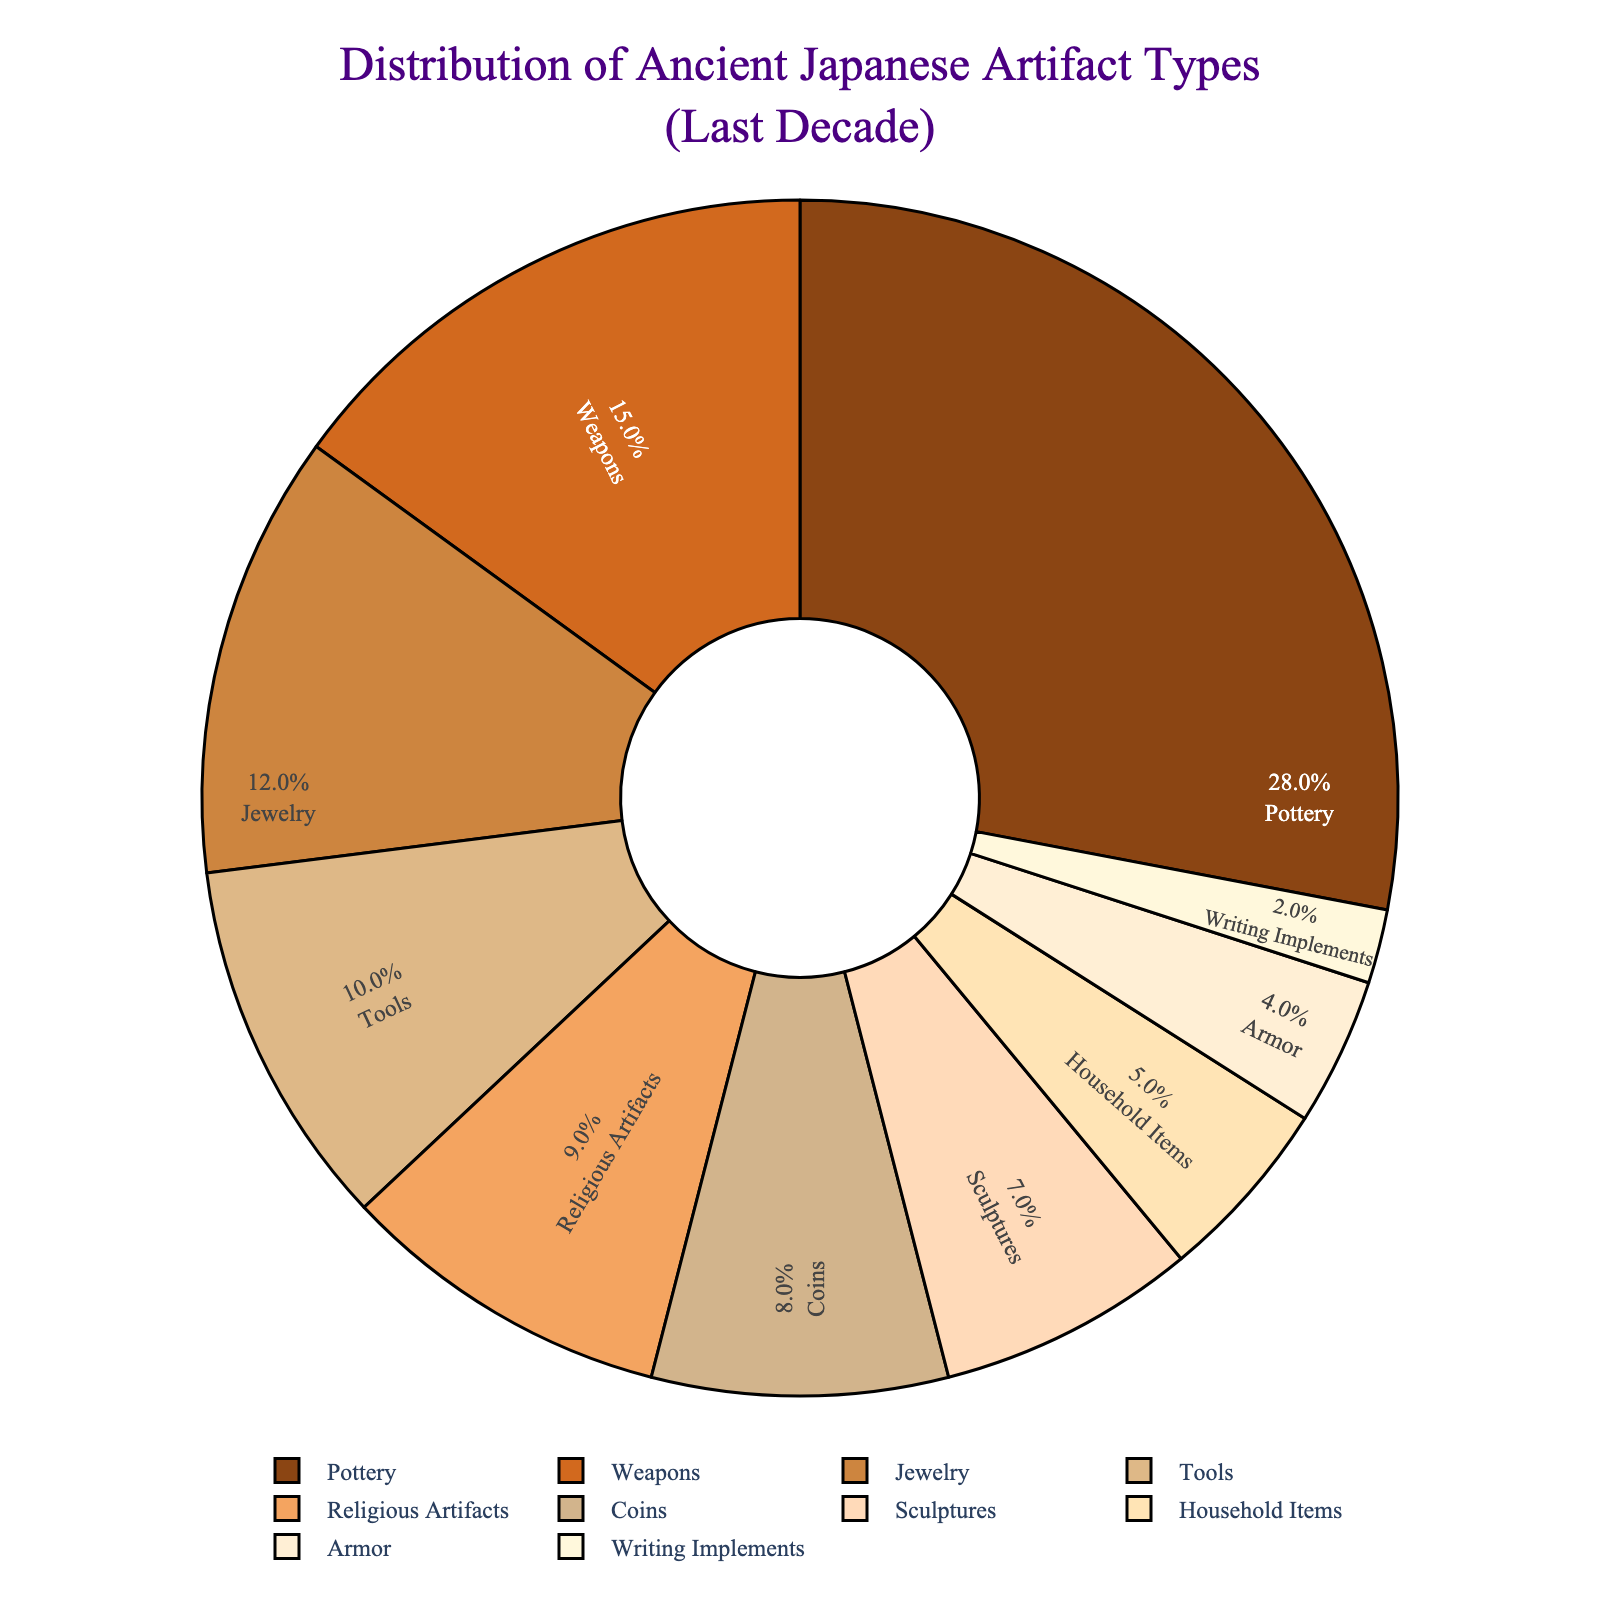Which artifact type has the highest percentage in the pie chart? The artifact type with the highest percentage will have the largest section in the pie chart. By looking at the pie chart, we can see that Pottery has the largest section.
Answer: Pottery Which artifact type has the lowest percentage in the pie chart? The artifact type with the lowest percentage will have the smallest section in the pie chart. By looking at the pie chart, Writing Implements has the smallest section.
Answer: Writing Implements What is the combined percentage of Pottery and Weapons? To find the combined percentage, add the individual percentages of Pottery and Weapons: 28% + 15% = 43%.
Answer: 43% How much more is the percentage of Jewelry compared to the percentage of Household Items? To find the difference, subtract the percentage of Household Items from Jewelry: 12% - 5% = 7%.
Answer: 7% Are there more Tools or Religious Artifacts in terms of percentage? Compare the percentage values of Tools and Religious Artifacts. Tools have 10%, and Religious Artifacts have 9%. Since 10% is greater than 9%, Tools have a higher percentage.
Answer: Tools What's the combined percentage of the three least common artifact types? The three least common artifact types are Writing Implements (2%), Armor (4%), and Household Items (5%). Their combined percentage is 2% + 4% + 5% = 11%.
Answer: 11% Which artifact type pair has a combined percentage equal to the percentage of Pottery? Looking at the percentages, we need to find a pair that sums to 28%. Weapons (15%) and Tools (10%) together make 15% + 10% = 25%. That’s not correct. Weapons (15%) and Jewelry (12%) together make 15% + 12% = 27%. That’s not correct either. Finally, adding Coins (8%) and Sculptures (7%) we get 8% + 7% = 15%. Still not correct. Therefore, no pair matches 28%. The closest match is not exact, but Weapons and Jewelry are largest close pair.
Answer: None exactly, closest pair is Weapons and Jewelry Which artifact has a darker brown color between Pottery and Sculptures? By looking at the pie chart, we see that the color for Pottery is darker compared to the color for Sculptures.
Answer: Pottery What is the percentage of artifacts that are not Pottery, Weapons, or Jewelry? First, find the percentage of the specific artifacts: Pottery (28%), Weapons (15%), and Jewelry (12%). Add them: 28% + 15% + 12% = 55%. Subtract this from 100% to find the remaining: 100% - 55% = 45%.
Answer: 45% What's the percentage difference between the most common and least common artifact types? The most common artifact type is Pottery (28%), and the least common is Writing Implements (2%). Find the difference: 28% - 2% = 26%.
Answer: 26% 